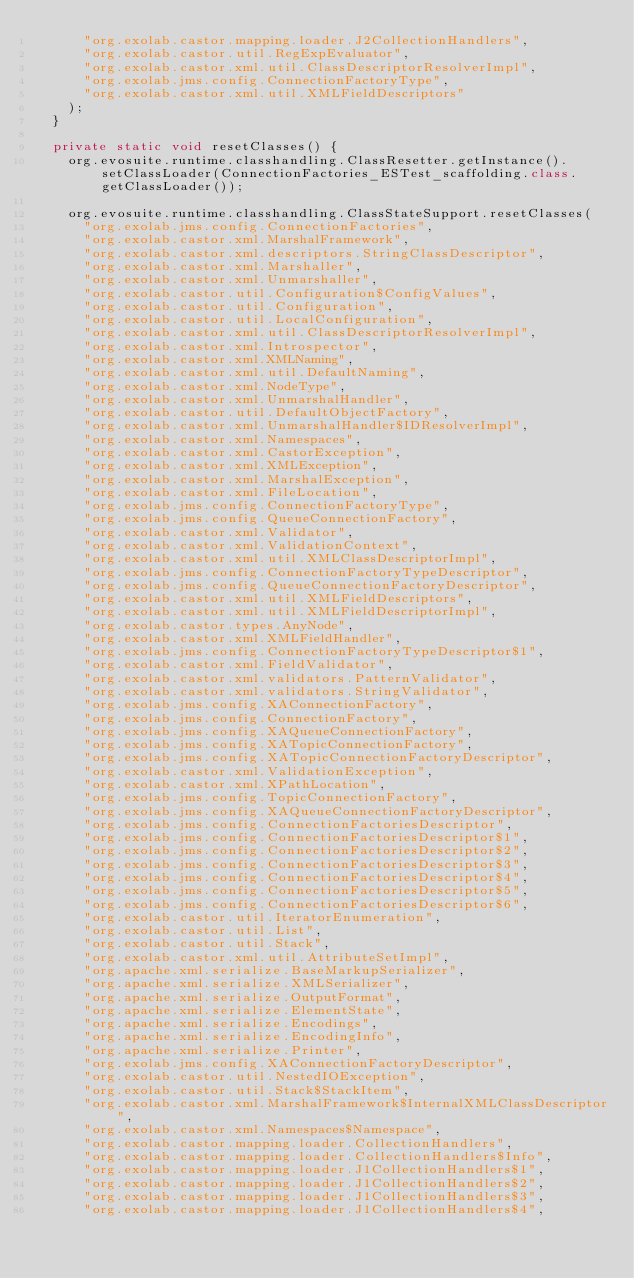<code> <loc_0><loc_0><loc_500><loc_500><_Java_>      "org.exolab.castor.mapping.loader.J2CollectionHandlers",
      "org.exolab.castor.util.RegExpEvaluator",
      "org.exolab.castor.xml.util.ClassDescriptorResolverImpl",
      "org.exolab.jms.config.ConnectionFactoryType",
      "org.exolab.castor.xml.util.XMLFieldDescriptors"
    );
  } 

  private static void resetClasses() {
    org.evosuite.runtime.classhandling.ClassResetter.getInstance().setClassLoader(ConnectionFactories_ESTest_scaffolding.class.getClassLoader()); 

    org.evosuite.runtime.classhandling.ClassStateSupport.resetClasses(
      "org.exolab.jms.config.ConnectionFactories",
      "org.exolab.castor.xml.MarshalFramework",
      "org.exolab.castor.xml.descriptors.StringClassDescriptor",
      "org.exolab.castor.xml.Marshaller",
      "org.exolab.castor.xml.Unmarshaller",
      "org.exolab.castor.util.Configuration$ConfigValues",
      "org.exolab.castor.util.Configuration",
      "org.exolab.castor.util.LocalConfiguration",
      "org.exolab.castor.xml.util.ClassDescriptorResolverImpl",
      "org.exolab.castor.xml.Introspector",
      "org.exolab.castor.xml.XMLNaming",
      "org.exolab.castor.xml.util.DefaultNaming",
      "org.exolab.castor.xml.NodeType",
      "org.exolab.castor.xml.UnmarshalHandler",
      "org.exolab.castor.util.DefaultObjectFactory",
      "org.exolab.castor.xml.UnmarshalHandler$IDResolverImpl",
      "org.exolab.castor.xml.Namespaces",
      "org.exolab.castor.xml.CastorException",
      "org.exolab.castor.xml.XMLException",
      "org.exolab.castor.xml.MarshalException",
      "org.exolab.castor.xml.FileLocation",
      "org.exolab.jms.config.ConnectionFactoryType",
      "org.exolab.jms.config.QueueConnectionFactory",
      "org.exolab.castor.xml.Validator",
      "org.exolab.castor.xml.ValidationContext",
      "org.exolab.castor.xml.util.XMLClassDescriptorImpl",
      "org.exolab.jms.config.ConnectionFactoryTypeDescriptor",
      "org.exolab.jms.config.QueueConnectionFactoryDescriptor",
      "org.exolab.castor.xml.util.XMLFieldDescriptors",
      "org.exolab.castor.xml.util.XMLFieldDescriptorImpl",
      "org.exolab.castor.types.AnyNode",
      "org.exolab.castor.xml.XMLFieldHandler",
      "org.exolab.jms.config.ConnectionFactoryTypeDescriptor$1",
      "org.exolab.castor.xml.FieldValidator",
      "org.exolab.castor.xml.validators.PatternValidator",
      "org.exolab.castor.xml.validators.StringValidator",
      "org.exolab.jms.config.XAConnectionFactory",
      "org.exolab.jms.config.ConnectionFactory",
      "org.exolab.jms.config.XAQueueConnectionFactory",
      "org.exolab.jms.config.XATopicConnectionFactory",
      "org.exolab.jms.config.XATopicConnectionFactoryDescriptor",
      "org.exolab.castor.xml.ValidationException",
      "org.exolab.castor.xml.XPathLocation",
      "org.exolab.jms.config.TopicConnectionFactory",
      "org.exolab.jms.config.XAQueueConnectionFactoryDescriptor",
      "org.exolab.jms.config.ConnectionFactoriesDescriptor",
      "org.exolab.jms.config.ConnectionFactoriesDescriptor$1",
      "org.exolab.jms.config.ConnectionFactoriesDescriptor$2",
      "org.exolab.jms.config.ConnectionFactoriesDescriptor$3",
      "org.exolab.jms.config.ConnectionFactoriesDescriptor$4",
      "org.exolab.jms.config.ConnectionFactoriesDescriptor$5",
      "org.exolab.jms.config.ConnectionFactoriesDescriptor$6",
      "org.exolab.castor.util.IteratorEnumeration",
      "org.exolab.castor.util.List",
      "org.exolab.castor.util.Stack",
      "org.exolab.castor.xml.util.AttributeSetImpl",
      "org.apache.xml.serialize.BaseMarkupSerializer",
      "org.apache.xml.serialize.XMLSerializer",
      "org.apache.xml.serialize.OutputFormat",
      "org.apache.xml.serialize.ElementState",
      "org.apache.xml.serialize.Encodings",
      "org.apache.xml.serialize.EncodingInfo",
      "org.apache.xml.serialize.Printer",
      "org.exolab.jms.config.XAConnectionFactoryDescriptor",
      "org.exolab.castor.util.NestedIOException",
      "org.exolab.castor.util.Stack$StackItem",
      "org.exolab.castor.xml.MarshalFramework$InternalXMLClassDescriptor",
      "org.exolab.castor.xml.Namespaces$Namespace",
      "org.exolab.castor.mapping.loader.CollectionHandlers",
      "org.exolab.castor.mapping.loader.CollectionHandlers$Info",
      "org.exolab.castor.mapping.loader.J1CollectionHandlers$1",
      "org.exolab.castor.mapping.loader.J1CollectionHandlers$2",
      "org.exolab.castor.mapping.loader.J1CollectionHandlers$3",
      "org.exolab.castor.mapping.loader.J1CollectionHandlers$4",</code> 